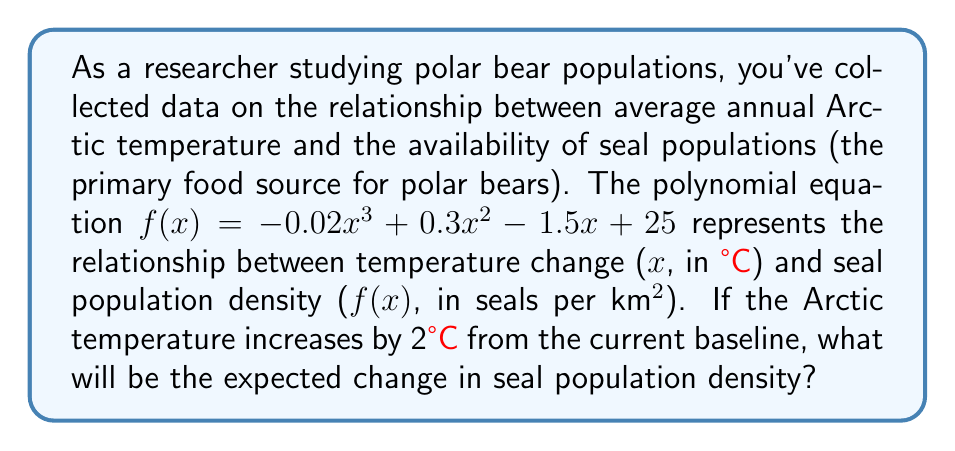Teach me how to tackle this problem. To solve this problem, we need to find the difference between the seal population density at the baseline temperature (x = 0) and the seal population density when the temperature increases by 2°C (x = 2).

1. Calculate the seal population density at baseline temperature (x = 0):
   $$f(0) = -0.02(0)^3 + 0.3(0)^2 - 1.5(0) + 25 = 25$$

2. Calculate the seal population density at 2°C increase (x = 2):
   $$f(2) = -0.02(2)^3 + 0.3(2)^2 - 1.5(2) + 25$$
   $$= -0.02(8) + 0.3(4) - 1.5(2) + 25$$
   $$= -0.16 + 1.2 - 3 + 25$$
   $$= 23.04$$

3. Calculate the change in seal population density:
   $$\text{Change} = f(2) - f(0) = 23.04 - 25 = -1.96$$

The negative value indicates a decrease in seal population density.
Answer: The expected change in seal population density is a decrease of 1.96 seals per km². 